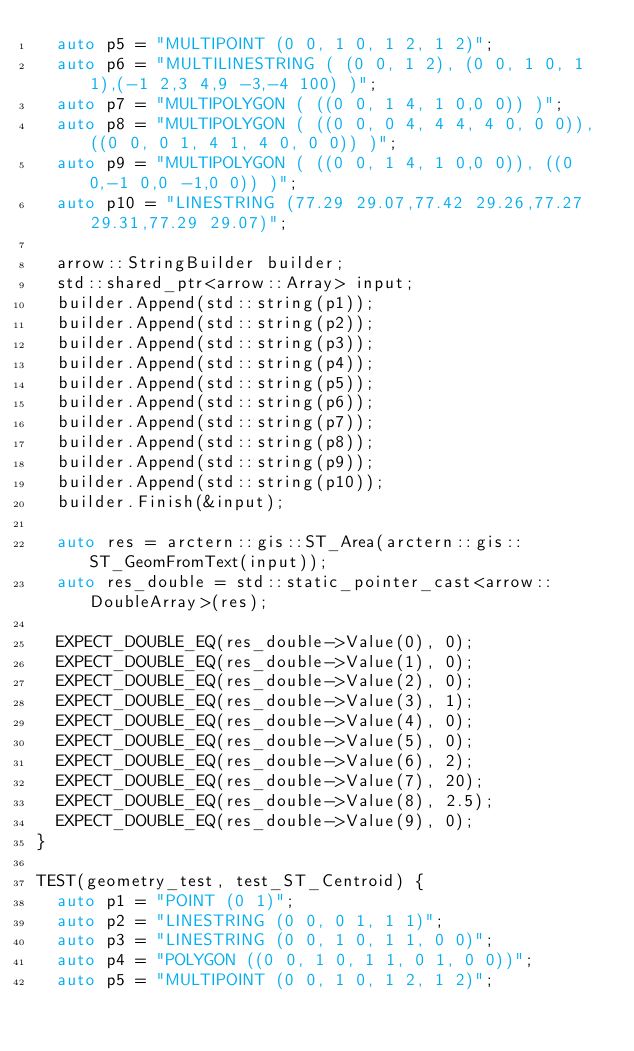Convert code to text. <code><loc_0><loc_0><loc_500><loc_500><_C++_>  auto p5 = "MULTIPOINT (0 0, 1 0, 1 2, 1 2)";
  auto p6 = "MULTILINESTRING ( (0 0, 1 2), (0 0, 1 0, 1 1),(-1 2,3 4,9 -3,-4 100) )";
  auto p7 = "MULTIPOLYGON ( ((0 0, 1 4, 1 0,0 0)) )";
  auto p8 = "MULTIPOLYGON ( ((0 0, 0 4, 4 4, 4 0, 0 0)), ((0 0, 0 1, 4 1, 4 0, 0 0)) )";
  auto p9 = "MULTIPOLYGON ( ((0 0, 1 4, 1 0,0 0)), ((0 0,-1 0,0 -1,0 0)) )";
  auto p10 = "LINESTRING (77.29 29.07,77.42 29.26,77.27 29.31,77.29 29.07)";

  arrow::StringBuilder builder;
  std::shared_ptr<arrow::Array> input;
  builder.Append(std::string(p1));
  builder.Append(std::string(p2));
  builder.Append(std::string(p3));
  builder.Append(std::string(p4));
  builder.Append(std::string(p5));
  builder.Append(std::string(p6));
  builder.Append(std::string(p7));
  builder.Append(std::string(p8));
  builder.Append(std::string(p9));
  builder.Append(std::string(p10));
  builder.Finish(&input);

  auto res = arctern::gis::ST_Area(arctern::gis::ST_GeomFromText(input));
  auto res_double = std::static_pointer_cast<arrow::DoubleArray>(res);

  EXPECT_DOUBLE_EQ(res_double->Value(0), 0);
  EXPECT_DOUBLE_EQ(res_double->Value(1), 0);
  EXPECT_DOUBLE_EQ(res_double->Value(2), 0);
  EXPECT_DOUBLE_EQ(res_double->Value(3), 1);
  EXPECT_DOUBLE_EQ(res_double->Value(4), 0);
  EXPECT_DOUBLE_EQ(res_double->Value(5), 0);
  EXPECT_DOUBLE_EQ(res_double->Value(6), 2);
  EXPECT_DOUBLE_EQ(res_double->Value(7), 20);
  EXPECT_DOUBLE_EQ(res_double->Value(8), 2.5);
  EXPECT_DOUBLE_EQ(res_double->Value(9), 0);
}

TEST(geometry_test, test_ST_Centroid) {
  auto p1 = "POINT (0 1)";
  auto p2 = "LINESTRING (0 0, 0 1, 1 1)";
  auto p3 = "LINESTRING (0 0, 1 0, 1 1, 0 0)";
  auto p4 = "POLYGON ((0 0, 1 0, 1 1, 0 1, 0 0))";
  auto p5 = "MULTIPOINT (0 0, 1 0, 1 2, 1 2)";</code> 